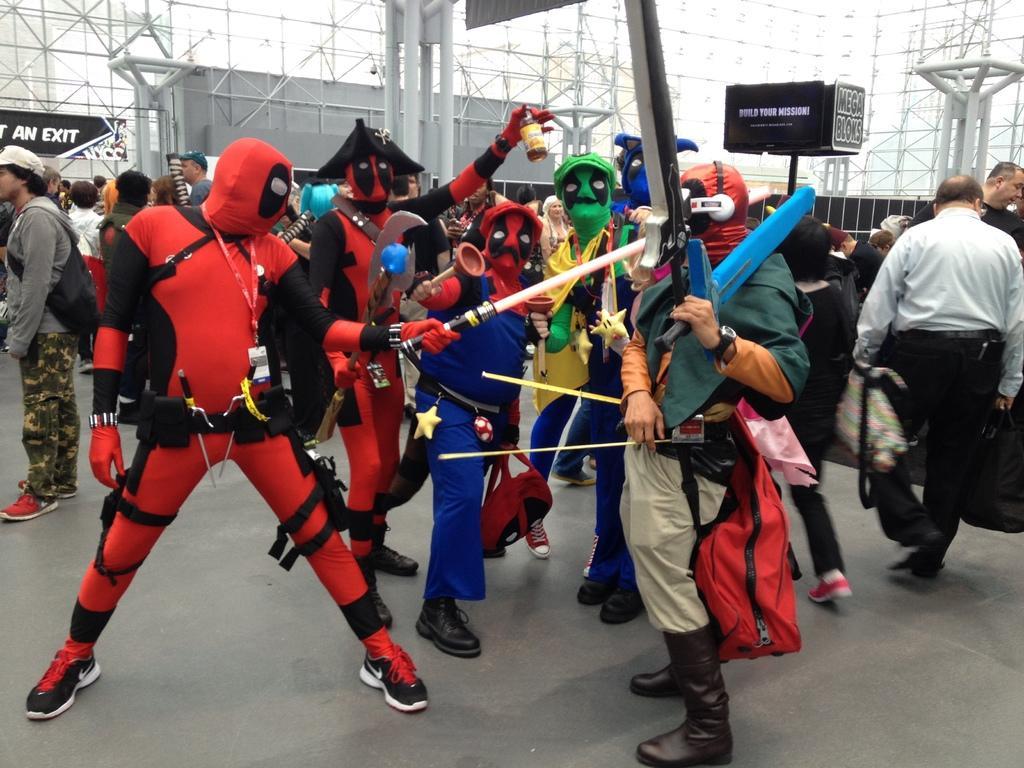In one or two sentences, can you explain what this image depicts? In this image I can see there are few persons wearing a colorful clothes and they are performing an act and they are holding the knives and at the top I can see rods and in the middle I can see some persons standing and walking on the road. 